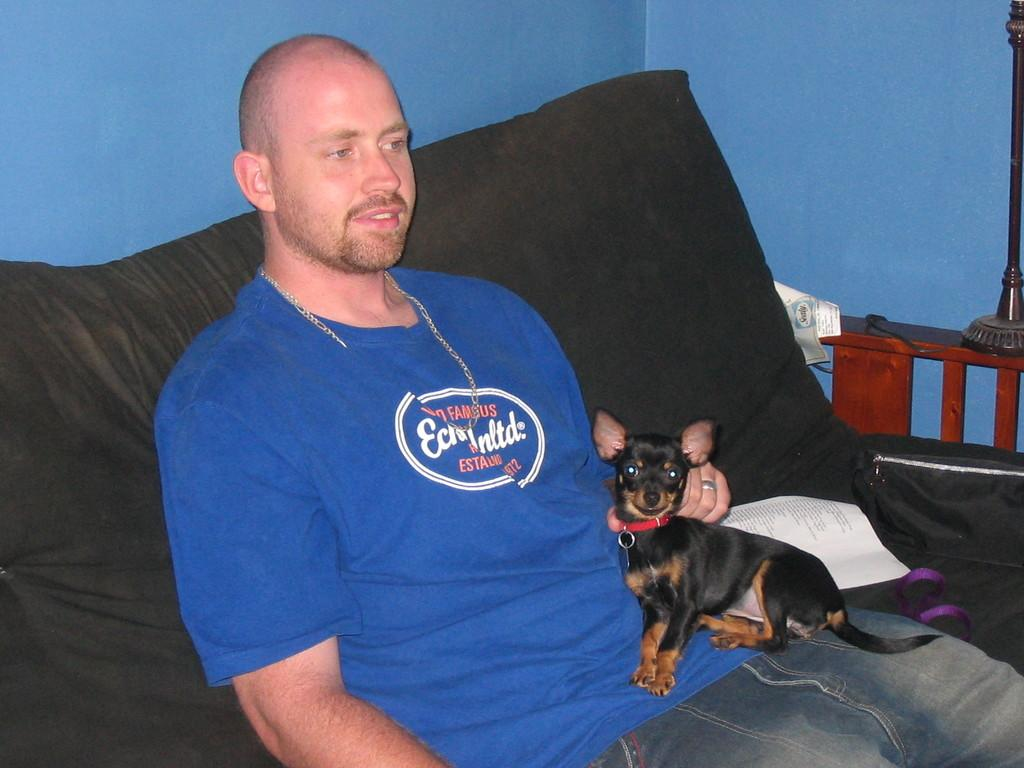Who is present in the image? There is a man in the image. What is the man doing in the image? The man is seated on a couch. What is the man holding in the image? The man is holding a dog with his hand. What else can be seen in the image? There is a paper visible in the image. What station is the man listening to in the image? There is no indication of a radio or any station in the image. 